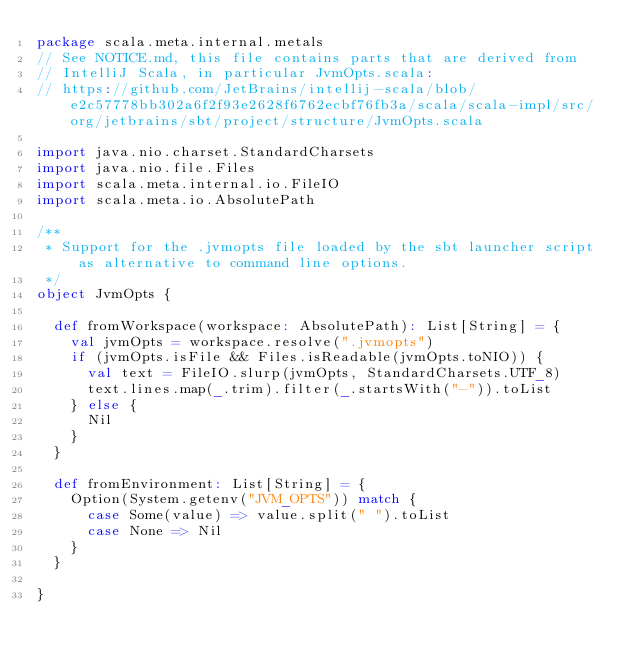Convert code to text. <code><loc_0><loc_0><loc_500><loc_500><_Scala_>package scala.meta.internal.metals
// See NOTICE.md, this file contains parts that are derived from
// IntelliJ Scala, in particular JvmOpts.scala:
// https://github.com/JetBrains/intellij-scala/blob/e2c57778bb302a6f2f93e2628f6762ecbf76fb3a/scala/scala-impl/src/org/jetbrains/sbt/project/structure/JvmOpts.scala

import java.nio.charset.StandardCharsets
import java.nio.file.Files
import scala.meta.internal.io.FileIO
import scala.meta.io.AbsolutePath

/**
 * Support for the .jvmopts file loaded by the sbt launcher script as alternative to command line options.
 */
object JvmOpts {

  def fromWorkspace(workspace: AbsolutePath): List[String] = {
    val jvmOpts = workspace.resolve(".jvmopts")
    if (jvmOpts.isFile && Files.isReadable(jvmOpts.toNIO)) {
      val text = FileIO.slurp(jvmOpts, StandardCharsets.UTF_8)
      text.lines.map(_.trim).filter(_.startsWith("-")).toList
    } else {
      Nil
    }
  }

  def fromEnvironment: List[String] = {
    Option(System.getenv("JVM_OPTS")) match {
      case Some(value) => value.split(" ").toList
      case None => Nil
    }
  }

}
</code> 